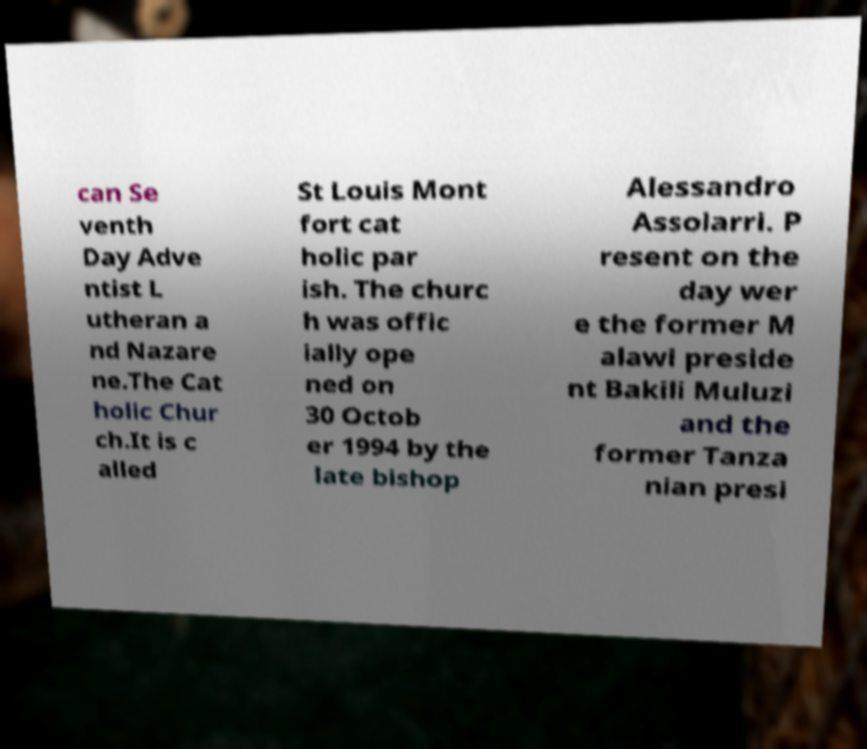Please identify and transcribe the text found in this image. can Se venth Day Adve ntist L utheran a nd Nazare ne.The Cat holic Chur ch.It is c alled St Louis Mont fort cat holic par ish. The churc h was offic ially ope ned on 30 Octob er 1994 by the late bishop Alessandro Assolarri. P resent on the day wer e the former M alawi preside nt Bakili Muluzi and the former Tanza nian presi 